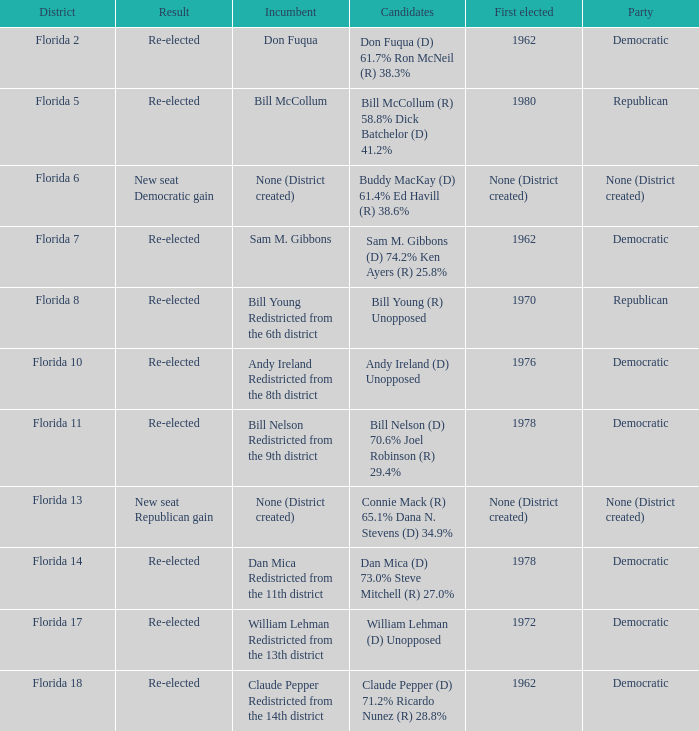Parse the full table. {'header': ['District', 'Result', 'Incumbent', 'Candidates', 'First elected', 'Party'], 'rows': [['Florida 2', 'Re-elected', 'Don Fuqua', 'Don Fuqua (D) 61.7% Ron McNeil (R) 38.3%', '1962', 'Democratic'], ['Florida 5', 'Re-elected', 'Bill McCollum', 'Bill McCollum (R) 58.8% Dick Batchelor (D) 41.2%', '1980', 'Republican'], ['Florida 6', 'New seat Democratic gain', 'None (District created)', 'Buddy MacKay (D) 61.4% Ed Havill (R) 38.6%', 'None (District created)', 'None (District created)'], ['Florida 7', 'Re-elected', 'Sam M. Gibbons', 'Sam M. Gibbons (D) 74.2% Ken Ayers (R) 25.8%', '1962', 'Democratic'], ['Florida 8', 'Re-elected', 'Bill Young Redistricted from the 6th district', 'Bill Young (R) Unopposed', '1970', 'Republican'], ['Florida 10', 'Re-elected', 'Andy Ireland Redistricted from the 8th district', 'Andy Ireland (D) Unopposed', '1976', 'Democratic'], ['Florida 11', 'Re-elected', 'Bill Nelson Redistricted from the 9th district', 'Bill Nelson (D) 70.6% Joel Robinson (R) 29.4%', '1978', 'Democratic'], ['Florida 13', 'New seat Republican gain', 'None (District created)', 'Connie Mack (R) 65.1% Dana N. Stevens (D) 34.9%', 'None (District created)', 'None (District created)'], ['Florida 14', 'Re-elected', 'Dan Mica Redistricted from the 11th district', 'Dan Mica (D) 73.0% Steve Mitchell (R) 27.0%', '1978', 'Democratic'], ['Florida 17', 'Re-elected', 'William Lehman Redistricted from the 13th district', 'William Lehman (D) Unopposed', '1972', 'Democratic'], ['Florida 18', 'Re-elected', 'Claude Pepper Redistricted from the 14th district', 'Claude Pepper (D) 71.2% Ricardo Nunez (R) 28.8%', '1962', 'Democratic']]}  how many result with district being florida 14 1.0. 